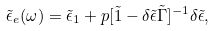<formula> <loc_0><loc_0><loc_500><loc_500>\tilde { \epsilon } _ { e } ( \omega ) = \tilde { \epsilon } _ { 1 } + p [ \tilde { 1 } - \delta \tilde { \epsilon } \tilde { \Gamma } ] ^ { - 1 } \delta \tilde { \epsilon } ,</formula> 